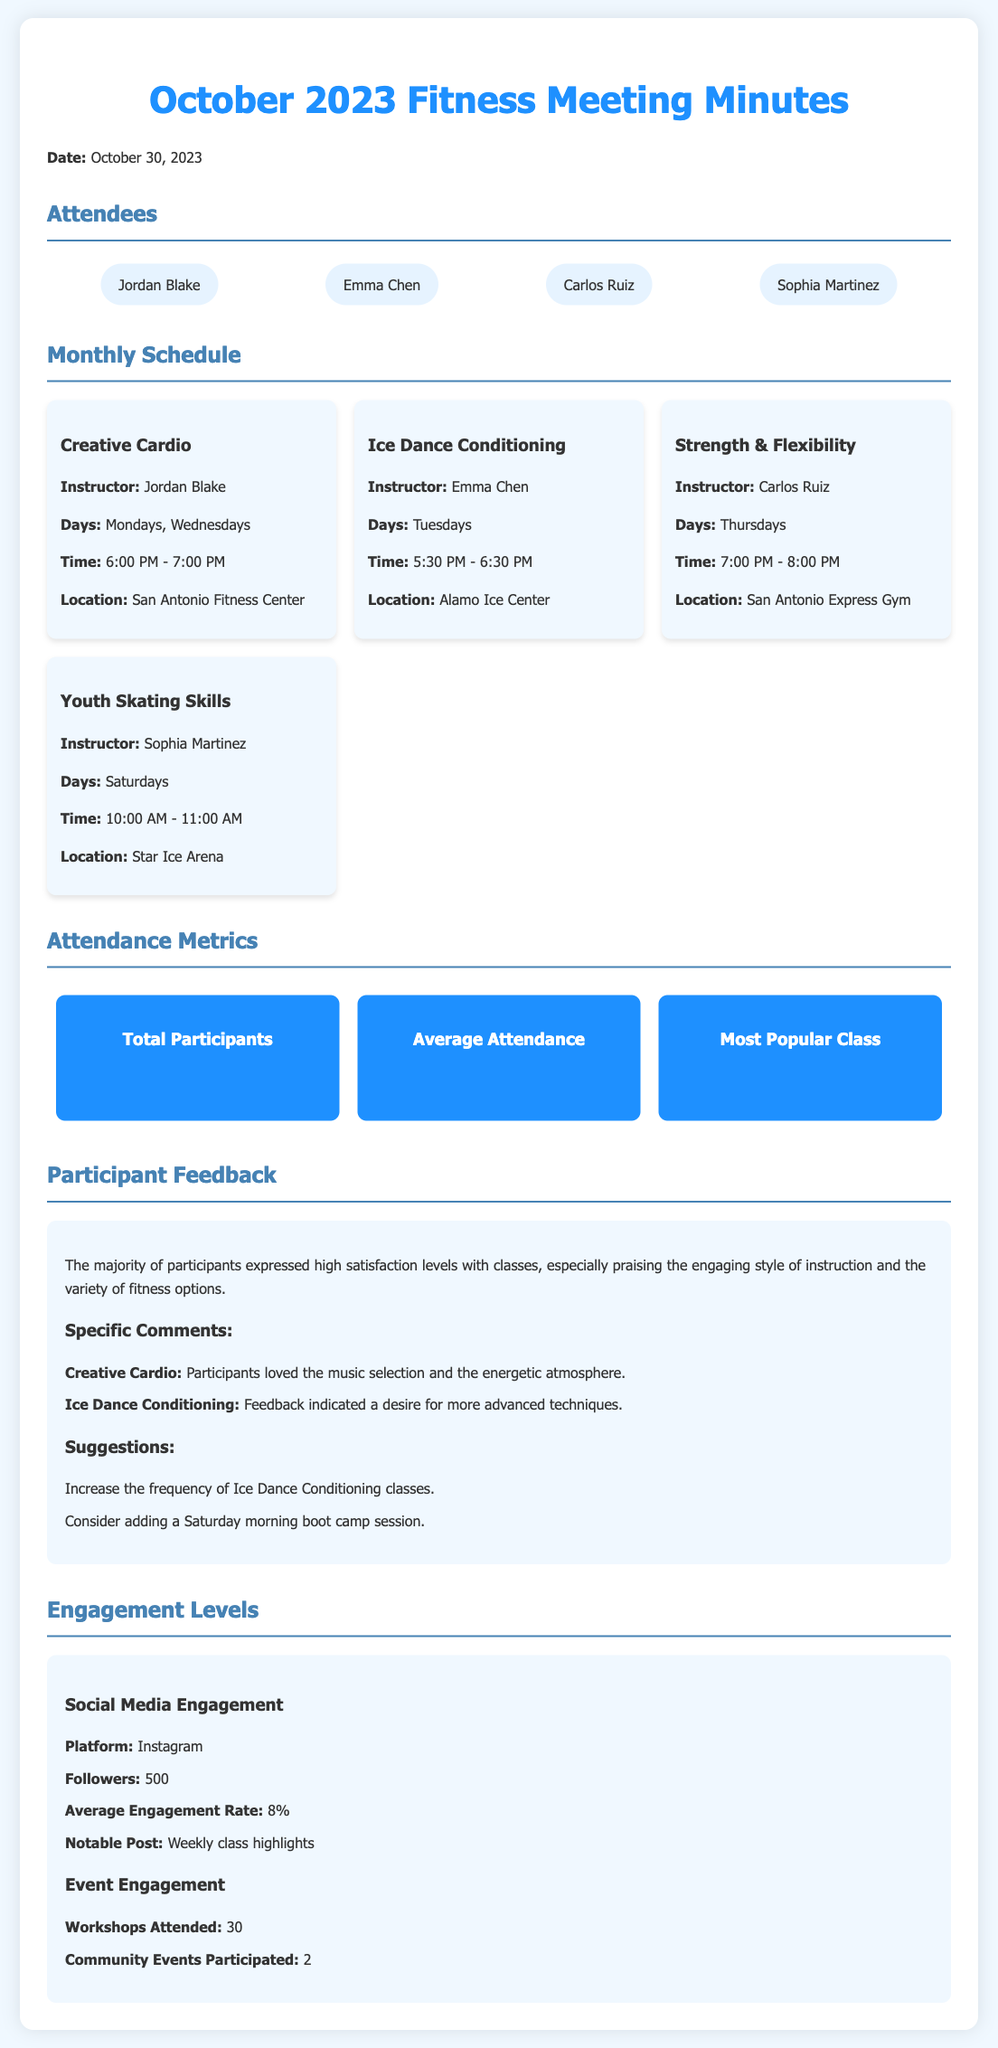What is the date of the meeting? The date of the meeting is stated in the document as October 30, 2023.
Answer: October 30, 2023 How many total participants were recorded? The total participants are provided in the metrics section as 120.
Answer: 120 Which class had the highest attendance? The most popular class is mentioned as Creative Cardio with 45 attendees.
Answer: Creative Cardio (45 attendees) What day is the Ice Dance Conditioning class scheduled? The document lists the days for the Ice Dance Conditioning class as Tuesdays.
Answer: Tuesdays What was a specific suggestion from participants? Suggestions made include increasing the frequency of Ice Dance Conditioning classes, which is mentioned in the feedback section.
Answer: Increase frequency of Ice Dance Conditioning classes How many workshops were attended according to the engagement metrics? The document specifies that 30 workshops were attended as part of event engagement.
Answer: 30 Who instructs the Strength & Flexibility class? The instructor for the Strength & Flexibility class is mentioned as Carlos Ruiz.
Answer: Carlos Ruiz What is the average attendance per class? The average attendance is listed in the metrics section as 30 per class.
Answer: 30 per class What is the engagement rate on Instagram? The average engagement rate for Instagram is stated as 8%.
Answer: 8% 